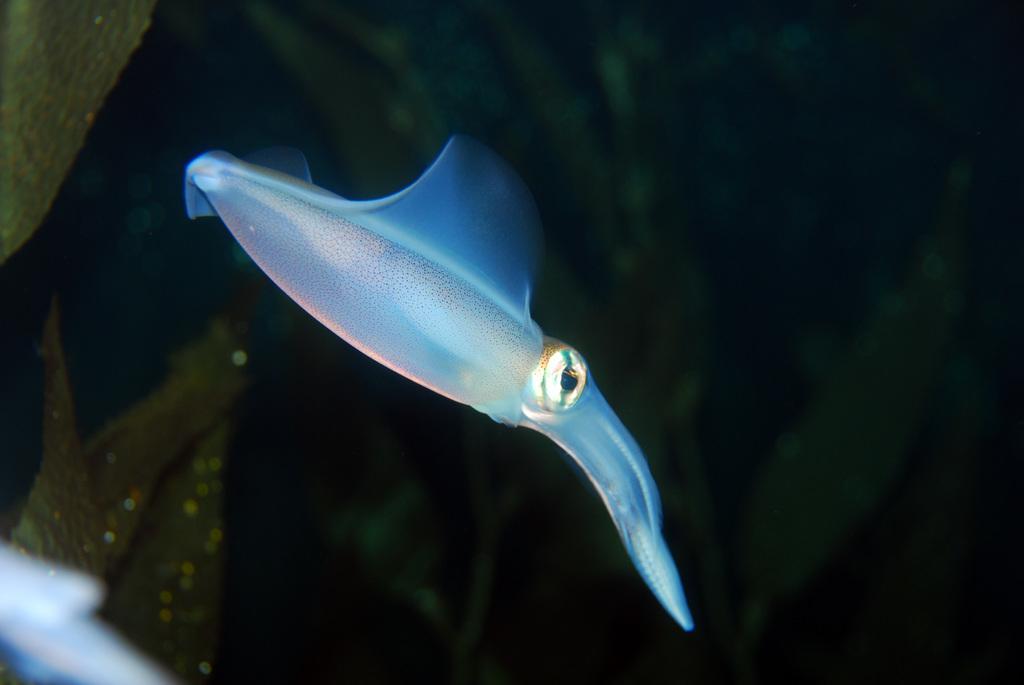Please provide a concise description of this image. In the image there is a squid swimming in the water and in the back there are aqua plants. 